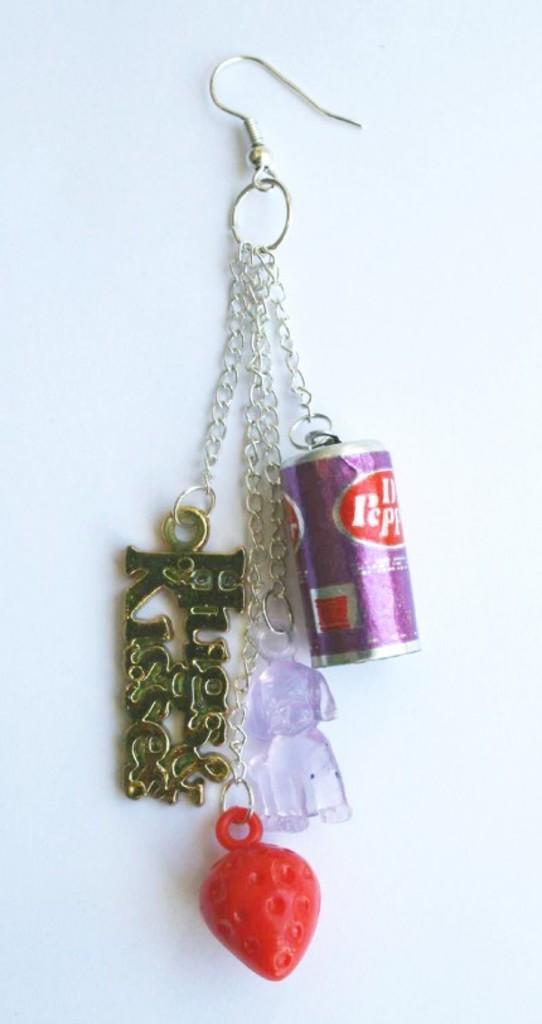Could you give a brief overview of what you see in this image? In this image we can see some objects attached to a hook. 